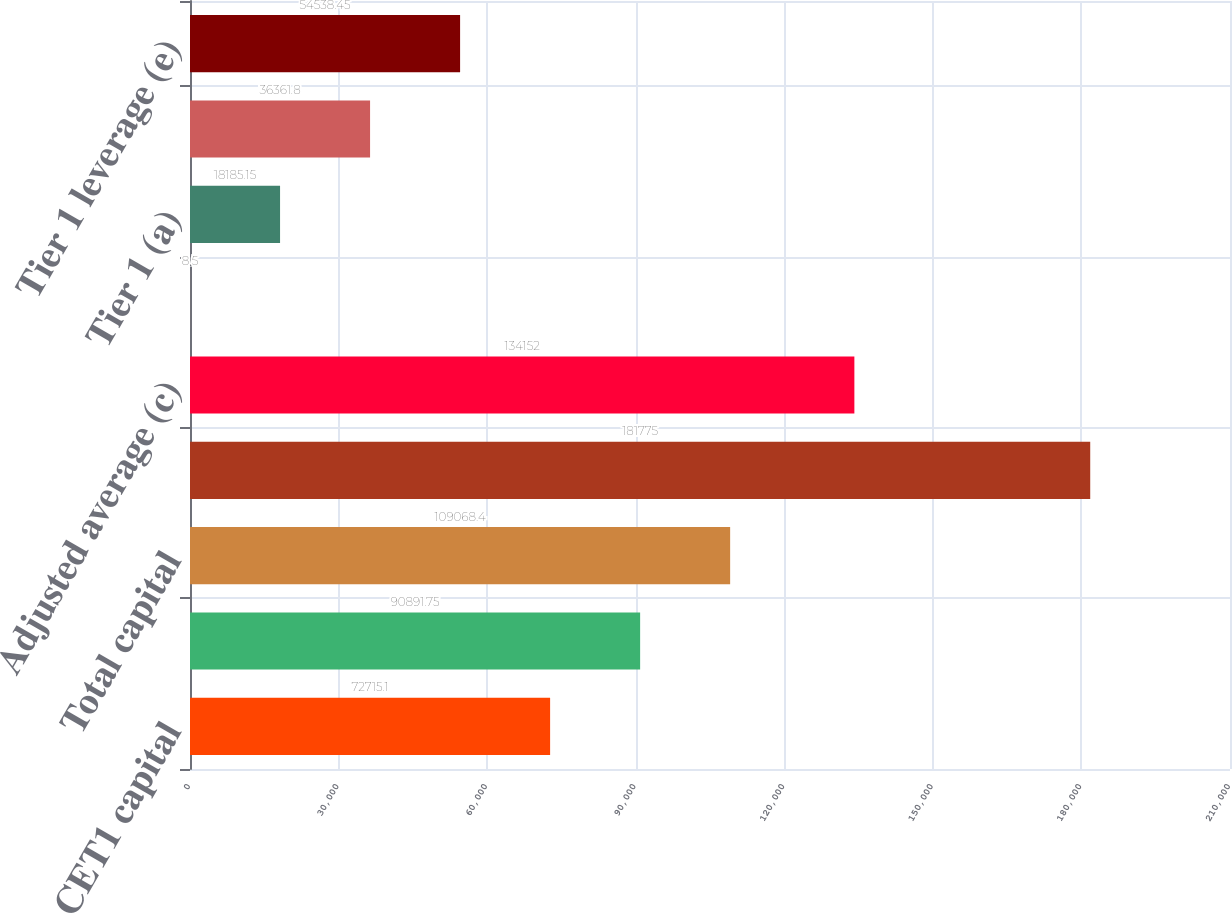Convert chart to OTSL. <chart><loc_0><loc_0><loc_500><loc_500><bar_chart><fcel>CET1 capital<fcel>Tier 1 capital (a)<fcel>Total capital<fcel>Risk-weighted (b)<fcel>Adjusted average (c)<fcel>CET1<fcel>Tier 1 (a)<fcel>Total<fcel>Tier 1 leverage (e)<nl><fcel>72715.1<fcel>90891.8<fcel>109068<fcel>181775<fcel>134152<fcel>8.5<fcel>18185.2<fcel>36361.8<fcel>54538.4<nl></chart> 